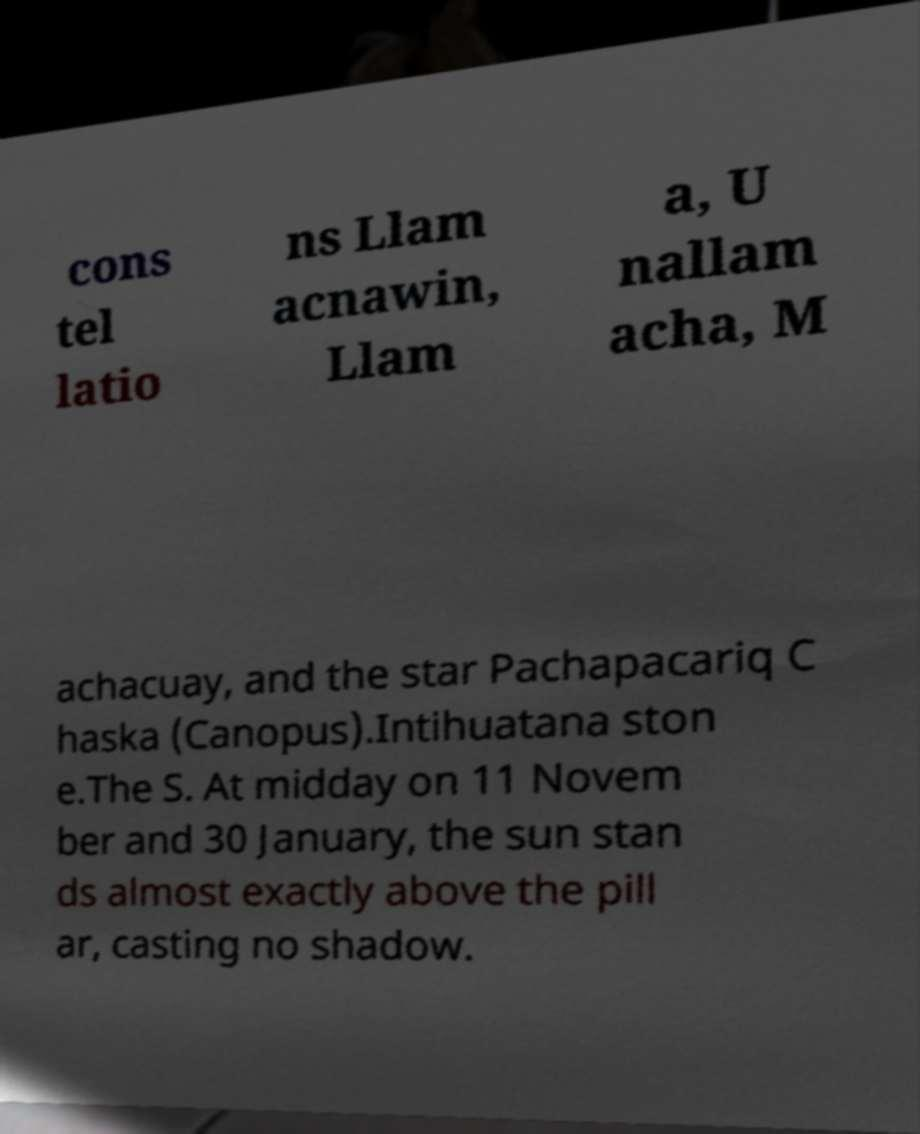Please identify and transcribe the text found in this image. cons tel latio ns Llam acnawin, Llam a, U nallam acha, M achacuay, and the star Pachapacariq C haska (Canopus).Intihuatana ston e.The S. At midday on 11 Novem ber and 30 January, the sun stan ds almost exactly above the pill ar, casting no shadow. 